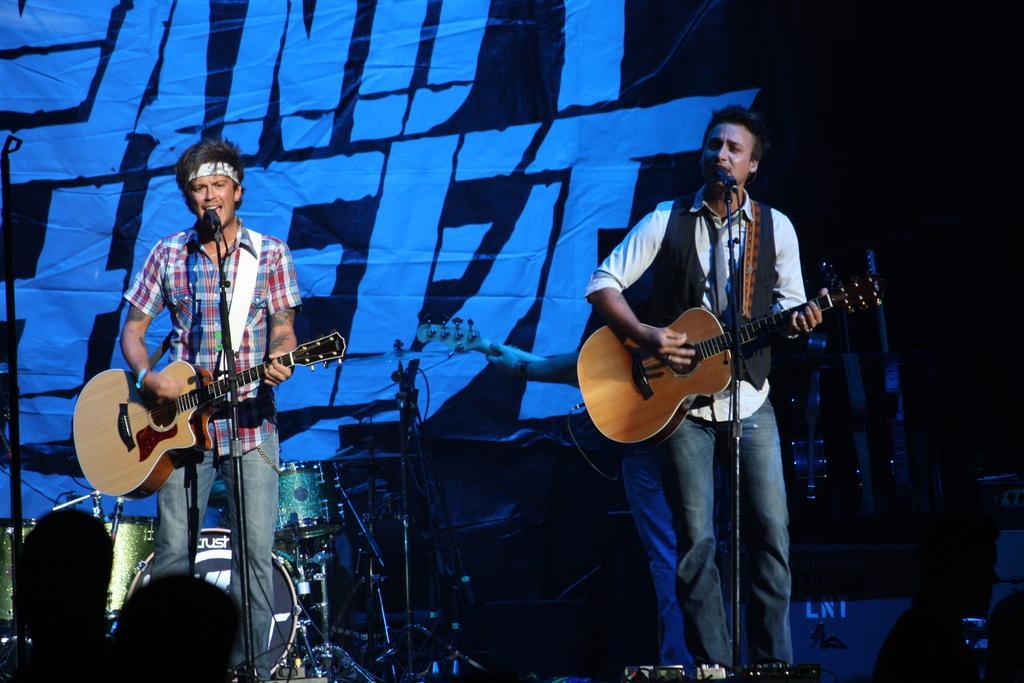How would you summarize this image in a sentence or two? Here we can see two persons are singing on the mike. They are playing guitars. These are some musical instruments. On the background there is a banner. 